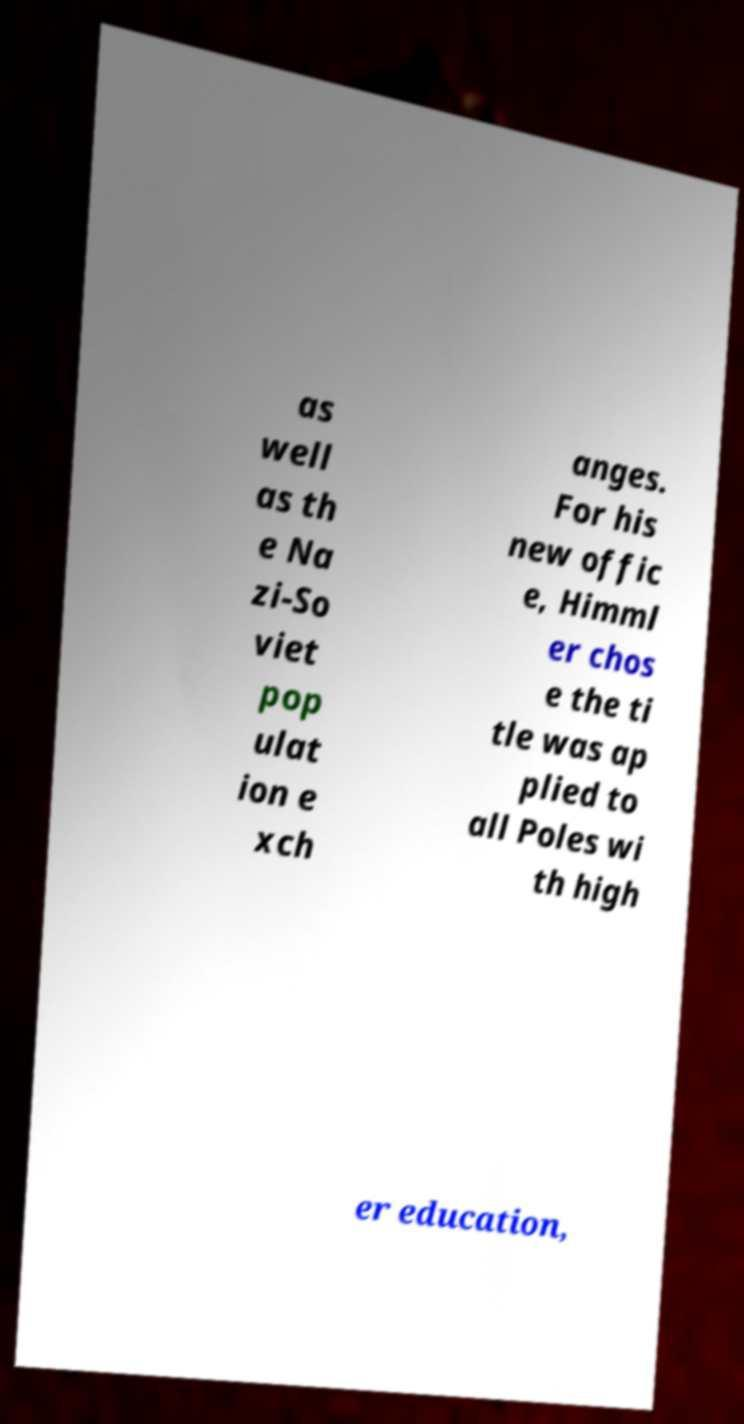Can you accurately transcribe the text from the provided image for me? as well as th e Na zi-So viet pop ulat ion e xch anges. For his new offic e, Himml er chos e the ti tle was ap plied to all Poles wi th high er education, 